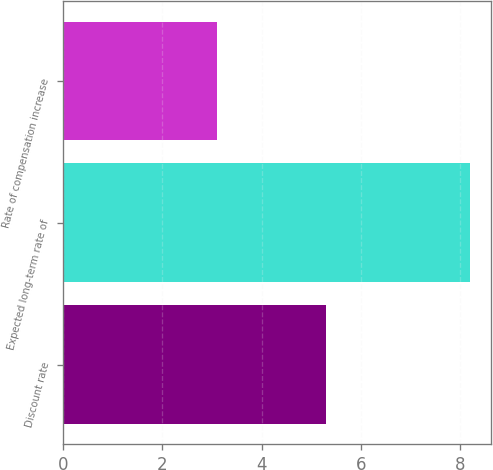Convert chart. <chart><loc_0><loc_0><loc_500><loc_500><bar_chart><fcel>Discount rate<fcel>Expected long-term rate of<fcel>Rate of compensation increase<nl><fcel>5.3<fcel>8.2<fcel>3.1<nl></chart> 